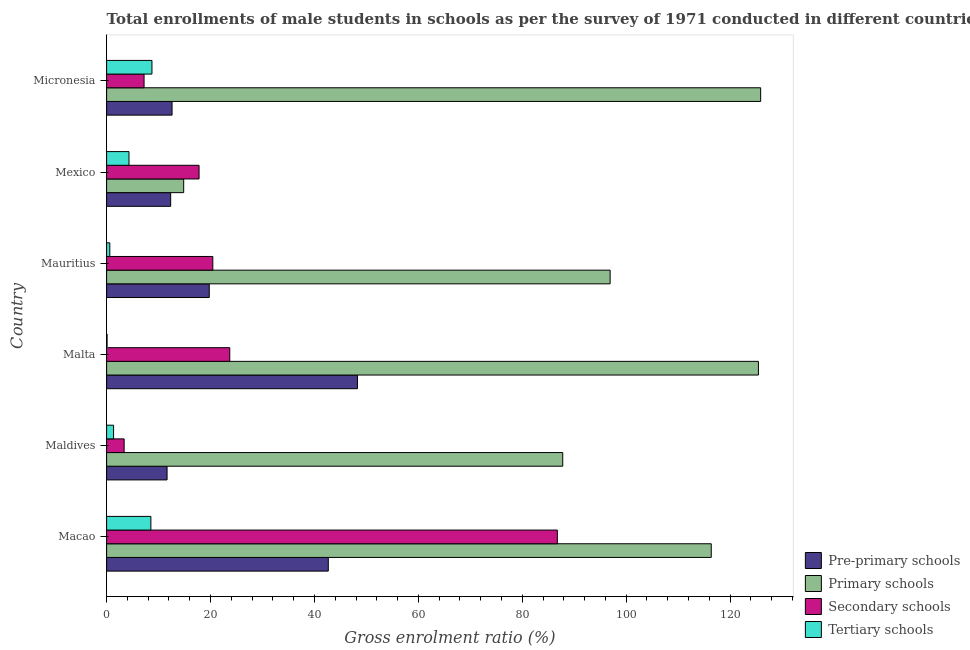How many different coloured bars are there?
Give a very brief answer. 4. How many groups of bars are there?
Provide a short and direct response. 6. Are the number of bars per tick equal to the number of legend labels?
Make the answer very short. Yes. Are the number of bars on each tick of the Y-axis equal?
Give a very brief answer. Yes. How many bars are there on the 5th tick from the top?
Ensure brevity in your answer.  4. What is the label of the 1st group of bars from the top?
Provide a succinct answer. Micronesia. In how many cases, is the number of bars for a given country not equal to the number of legend labels?
Your answer should be compact. 0. What is the gross enrolment ratio(male) in pre-primary schools in Maldives?
Your answer should be very brief. 11.64. Across all countries, what is the maximum gross enrolment ratio(male) in pre-primary schools?
Keep it short and to the point. 48.28. Across all countries, what is the minimum gross enrolment ratio(male) in primary schools?
Your answer should be very brief. 14.84. In which country was the gross enrolment ratio(male) in pre-primary schools maximum?
Your answer should be very brief. Malta. In which country was the gross enrolment ratio(male) in secondary schools minimum?
Ensure brevity in your answer.  Maldives. What is the total gross enrolment ratio(male) in primary schools in the graph?
Offer a very short reply. 567.22. What is the difference between the gross enrolment ratio(male) in primary schools in Macao and that in Micronesia?
Make the answer very short. -9.51. What is the difference between the gross enrolment ratio(male) in tertiary schools in Maldives and the gross enrolment ratio(male) in pre-primary schools in Micronesia?
Give a very brief answer. -11.25. What is the average gross enrolment ratio(male) in tertiary schools per country?
Give a very brief answer. 3.93. What is the difference between the gross enrolment ratio(male) in pre-primary schools and gross enrolment ratio(male) in primary schools in Maldives?
Ensure brevity in your answer.  -76.15. What is the ratio of the gross enrolment ratio(male) in pre-primary schools in Malta to that in Micronesia?
Provide a succinct answer. 3.83. What is the difference between the highest and the second highest gross enrolment ratio(male) in secondary schools?
Give a very brief answer. 63.05. What is the difference between the highest and the lowest gross enrolment ratio(male) in primary schools?
Offer a very short reply. 111.04. Is the sum of the gross enrolment ratio(male) in secondary schools in Mexico and Micronesia greater than the maximum gross enrolment ratio(male) in primary schools across all countries?
Your response must be concise. No. Is it the case that in every country, the sum of the gross enrolment ratio(male) in pre-primary schools and gross enrolment ratio(male) in tertiary schools is greater than the sum of gross enrolment ratio(male) in primary schools and gross enrolment ratio(male) in secondary schools?
Ensure brevity in your answer.  Yes. What does the 3rd bar from the top in Maldives represents?
Offer a very short reply. Primary schools. What does the 1st bar from the bottom in Micronesia represents?
Make the answer very short. Pre-primary schools. Is it the case that in every country, the sum of the gross enrolment ratio(male) in pre-primary schools and gross enrolment ratio(male) in primary schools is greater than the gross enrolment ratio(male) in secondary schools?
Make the answer very short. Yes. What is the difference between two consecutive major ticks on the X-axis?
Provide a succinct answer. 20. Are the values on the major ticks of X-axis written in scientific E-notation?
Make the answer very short. No. Does the graph contain any zero values?
Provide a short and direct response. No. How many legend labels are there?
Give a very brief answer. 4. What is the title of the graph?
Your response must be concise. Total enrollments of male students in schools as per the survey of 1971 conducted in different countries. What is the Gross enrolment ratio (%) in Pre-primary schools in Macao?
Your answer should be compact. 42.67. What is the Gross enrolment ratio (%) in Primary schools in Macao?
Provide a short and direct response. 116.37. What is the Gross enrolment ratio (%) in Secondary schools in Macao?
Ensure brevity in your answer.  86.75. What is the Gross enrolment ratio (%) in Tertiary schools in Macao?
Offer a very short reply. 8.52. What is the Gross enrolment ratio (%) in Pre-primary schools in Maldives?
Make the answer very short. 11.64. What is the Gross enrolment ratio (%) in Primary schools in Maldives?
Your answer should be compact. 87.79. What is the Gross enrolment ratio (%) in Secondary schools in Maldives?
Offer a very short reply. 3.38. What is the Gross enrolment ratio (%) in Tertiary schools in Maldives?
Keep it short and to the point. 1.34. What is the Gross enrolment ratio (%) in Pre-primary schools in Malta?
Your answer should be compact. 48.28. What is the Gross enrolment ratio (%) in Primary schools in Malta?
Offer a very short reply. 125.45. What is the Gross enrolment ratio (%) in Secondary schools in Malta?
Provide a short and direct response. 23.7. What is the Gross enrolment ratio (%) in Tertiary schools in Malta?
Provide a short and direct response. 0.09. What is the Gross enrolment ratio (%) in Pre-primary schools in Mauritius?
Provide a short and direct response. 19.76. What is the Gross enrolment ratio (%) in Primary schools in Mauritius?
Your answer should be very brief. 96.91. What is the Gross enrolment ratio (%) in Secondary schools in Mauritius?
Provide a succinct answer. 20.44. What is the Gross enrolment ratio (%) of Tertiary schools in Mauritius?
Your answer should be very brief. 0.62. What is the Gross enrolment ratio (%) of Pre-primary schools in Mexico?
Your answer should be compact. 12.33. What is the Gross enrolment ratio (%) in Primary schools in Mexico?
Provide a short and direct response. 14.84. What is the Gross enrolment ratio (%) of Secondary schools in Mexico?
Your answer should be very brief. 17.79. What is the Gross enrolment ratio (%) of Tertiary schools in Mexico?
Your response must be concise. 4.31. What is the Gross enrolment ratio (%) of Pre-primary schools in Micronesia?
Keep it short and to the point. 12.6. What is the Gross enrolment ratio (%) of Primary schools in Micronesia?
Keep it short and to the point. 125.88. What is the Gross enrolment ratio (%) in Secondary schools in Micronesia?
Offer a very short reply. 7.21. What is the Gross enrolment ratio (%) in Tertiary schools in Micronesia?
Make the answer very short. 8.73. Across all countries, what is the maximum Gross enrolment ratio (%) in Pre-primary schools?
Ensure brevity in your answer.  48.28. Across all countries, what is the maximum Gross enrolment ratio (%) of Primary schools?
Offer a very short reply. 125.88. Across all countries, what is the maximum Gross enrolment ratio (%) in Secondary schools?
Provide a succinct answer. 86.75. Across all countries, what is the maximum Gross enrolment ratio (%) of Tertiary schools?
Offer a very short reply. 8.73. Across all countries, what is the minimum Gross enrolment ratio (%) of Pre-primary schools?
Your response must be concise. 11.64. Across all countries, what is the minimum Gross enrolment ratio (%) of Primary schools?
Give a very brief answer. 14.84. Across all countries, what is the minimum Gross enrolment ratio (%) in Secondary schools?
Make the answer very short. 3.38. Across all countries, what is the minimum Gross enrolment ratio (%) of Tertiary schools?
Your answer should be compact. 0.09. What is the total Gross enrolment ratio (%) of Pre-primary schools in the graph?
Keep it short and to the point. 147.26. What is the total Gross enrolment ratio (%) of Primary schools in the graph?
Ensure brevity in your answer.  567.22. What is the total Gross enrolment ratio (%) of Secondary schools in the graph?
Provide a succinct answer. 159.27. What is the total Gross enrolment ratio (%) of Tertiary schools in the graph?
Your answer should be very brief. 23.6. What is the difference between the Gross enrolment ratio (%) of Pre-primary schools in Macao and that in Maldives?
Keep it short and to the point. 31.03. What is the difference between the Gross enrolment ratio (%) of Primary schools in Macao and that in Maldives?
Your answer should be very brief. 28.58. What is the difference between the Gross enrolment ratio (%) in Secondary schools in Macao and that in Maldives?
Your answer should be very brief. 83.37. What is the difference between the Gross enrolment ratio (%) in Tertiary schools in Macao and that in Maldives?
Make the answer very short. 7.18. What is the difference between the Gross enrolment ratio (%) of Pre-primary schools in Macao and that in Malta?
Offer a very short reply. -5.61. What is the difference between the Gross enrolment ratio (%) of Primary schools in Macao and that in Malta?
Your response must be concise. -9.08. What is the difference between the Gross enrolment ratio (%) in Secondary schools in Macao and that in Malta?
Give a very brief answer. 63.05. What is the difference between the Gross enrolment ratio (%) in Tertiary schools in Macao and that in Malta?
Keep it short and to the point. 8.43. What is the difference between the Gross enrolment ratio (%) of Pre-primary schools in Macao and that in Mauritius?
Your answer should be compact. 22.91. What is the difference between the Gross enrolment ratio (%) in Primary schools in Macao and that in Mauritius?
Your answer should be compact. 19.46. What is the difference between the Gross enrolment ratio (%) of Secondary schools in Macao and that in Mauritius?
Offer a very short reply. 66.31. What is the difference between the Gross enrolment ratio (%) in Tertiary schools in Macao and that in Mauritius?
Keep it short and to the point. 7.9. What is the difference between the Gross enrolment ratio (%) in Pre-primary schools in Macao and that in Mexico?
Your response must be concise. 30.33. What is the difference between the Gross enrolment ratio (%) in Primary schools in Macao and that in Mexico?
Offer a terse response. 101.53. What is the difference between the Gross enrolment ratio (%) in Secondary schools in Macao and that in Mexico?
Provide a succinct answer. 68.96. What is the difference between the Gross enrolment ratio (%) of Tertiary schools in Macao and that in Mexico?
Offer a terse response. 4.21. What is the difference between the Gross enrolment ratio (%) in Pre-primary schools in Macao and that in Micronesia?
Offer a terse response. 30.07. What is the difference between the Gross enrolment ratio (%) in Primary schools in Macao and that in Micronesia?
Provide a succinct answer. -9.51. What is the difference between the Gross enrolment ratio (%) in Secondary schools in Macao and that in Micronesia?
Your answer should be very brief. 79.54. What is the difference between the Gross enrolment ratio (%) in Tertiary schools in Macao and that in Micronesia?
Your answer should be compact. -0.21. What is the difference between the Gross enrolment ratio (%) in Pre-primary schools in Maldives and that in Malta?
Ensure brevity in your answer.  -36.64. What is the difference between the Gross enrolment ratio (%) in Primary schools in Maldives and that in Malta?
Offer a very short reply. -37.66. What is the difference between the Gross enrolment ratio (%) of Secondary schools in Maldives and that in Malta?
Your answer should be very brief. -20.33. What is the difference between the Gross enrolment ratio (%) in Tertiary schools in Maldives and that in Malta?
Your answer should be compact. 1.25. What is the difference between the Gross enrolment ratio (%) in Pre-primary schools in Maldives and that in Mauritius?
Ensure brevity in your answer.  -8.12. What is the difference between the Gross enrolment ratio (%) of Primary schools in Maldives and that in Mauritius?
Provide a succinct answer. -9.12. What is the difference between the Gross enrolment ratio (%) of Secondary schools in Maldives and that in Mauritius?
Your response must be concise. -17.06. What is the difference between the Gross enrolment ratio (%) of Tertiary schools in Maldives and that in Mauritius?
Your answer should be very brief. 0.73. What is the difference between the Gross enrolment ratio (%) in Pre-primary schools in Maldives and that in Mexico?
Your response must be concise. -0.69. What is the difference between the Gross enrolment ratio (%) in Primary schools in Maldives and that in Mexico?
Offer a very short reply. 72.95. What is the difference between the Gross enrolment ratio (%) in Secondary schools in Maldives and that in Mexico?
Make the answer very short. -14.42. What is the difference between the Gross enrolment ratio (%) of Tertiary schools in Maldives and that in Mexico?
Ensure brevity in your answer.  -2.97. What is the difference between the Gross enrolment ratio (%) in Pre-primary schools in Maldives and that in Micronesia?
Provide a short and direct response. -0.96. What is the difference between the Gross enrolment ratio (%) of Primary schools in Maldives and that in Micronesia?
Your response must be concise. -38.09. What is the difference between the Gross enrolment ratio (%) in Secondary schools in Maldives and that in Micronesia?
Offer a very short reply. -3.83. What is the difference between the Gross enrolment ratio (%) in Tertiary schools in Maldives and that in Micronesia?
Make the answer very short. -7.38. What is the difference between the Gross enrolment ratio (%) of Pre-primary schools in Malta and that in Mauritius?
Keep it short and to the point. 28.52. What is the difference between the Gross enrolment ratio (%) of Primary schools in Malta and that in Mauritius?
Keep it short and to the point. 28.54. What is the difference between the Gross enrolment ratio (%) in Secondary schools in Malta and that in Mauritius?
Your answer should be very brief. 3.26. What is the difference between the Gross enrolment ratio (%) of Tertiary schools in Malta and that in Mauritius?
Make the answer very short. -0.53. What is the difference between the Gross enrolment ratio (%) of Pre-primary schools in Malta and that in Mexico?
Give a very brief answer. 35.95. What is the difference between the Gross enrolment ratio (%) of Primary schools in Malta and that in Mexico?
Give a very brief answer. 110.61. What is the difference between the Gross enrolment ratio (%) in Secondary schools in Malta and that in Mexico?
Ensure brevity in your answer.  5.91. What is the difference between the Gross enrolment ratio (%) of Tertiary schools in Malta and that in Mexico?
Your answer should be very brief. -4.22. What is the difference between the Gross enrolment ratio (%) in Pre-primary schools in Malta and that in Micronesia?
Offer a very short reply. 35.68. What is the difference between the Gross enrolment ratio (%) of Primary schools in Malta and that in Micronesia?
Your answer should be compact. -0.43. What is the difference between the Gross enrolment ratio (%) of Secondary schools in Malta and that in Micronesia?
Make the answer very short. 16.49. What is the difference between the Gross enrolment ratio (%) in Tertiary schools in Malta and that in Micronesia?
Ensure brevity in your answer.  -8.64. What is the difference between the Gross enrolment ratio (%) of Pre-primary schools in Mauritius and that in Mexico?
Make the answer very short. 7.43. What is the difference between the Gross enrolment ratio (%) in Primary schools in Mauritius and that in Mexico?
Give a very brief answer. 82.07. What is the difference between the Gross enrolment ratio (%) of Secondary schools in Mauritius and that in Mexico?
Provide a short and direct response. 2.65. What is the difference between the Gross enrolment ratio (%) of Tertiary schools in Mauritius and that in Mexico?
Give a very brief answer. -3.69. What is the difference between the Gross enrolment ratio (%) of Pre-primary schools in Mauritius and that in Micronesia?
Provide a short and direct response. 7.16. What is the difference between the Gross enrolment ratio (%) of Primary schools in Mauritius and that in Micronesia?
Keep it short and to the point. -28.97. What is the difference between the Gross enrolment ratio (%) in Secondary schools in Mauritius and that in Micronesia?
Make the answer very short. 13.23. What is the difference between the Gross enrolment ratio (%) in Tertiary schools in Mauritius and that in Micronesia?
Offer a terse response. -8.11. What is the difference between the Gross enrolment ratio (%) in Pre-primary schools in Mexico and that in Micronesia?
Give a very brief answer. -0.27. What is the difference between the Gross enrolment ratio (%) of Primary schools in Mexico and that in Micronesia?
Your answer should be compact. -111.04. What is the difference between the Gross enrolment ratio (%) of Secondary schools in Mexico and that in Micronesia?
Your answer should be very brief. 10.58. What is the difference between the Gross enrolment ratio (%) of Tertiary schools in Mexico and that in Micronesia?
Offer a very short reply. -4.42. What is the difference between the Gross enrolment ratio (%) in Pre-primary schools in Macao and the Gross enrolment ratio (%) in Primary schools in Maldives?
Your response must be concise. -45.12. What is the difference between the Gross enrolment ratio (%) in Pre-primary schools in Macao and the Gross enrolment ratio (%) in Secondary schools in Maldives?
Ensure brevity in your answer.  39.29. What is the difference between the Gross enrolment ratio (%) in Pre-primary schools in Macao and the Gross enrolment ratio (%) in Tertiary schools in Maldives?
Your answer should be compact. 41.32. What is the difference between the Gross enrolment ratio (%) in Primary schools in Macao and the Gross enrolment ratio (%) in Secondary schools in Maldives?
Give a very brief answer. 112.99. What is the difference between the Gross enrolment ratio (%) of Primary schools in Macao and the Gross enrolment ratio (%) of Tertiary schools in Maldives?
Provide a short and direct response. 115.02. What is the difference between the Gross enrolment ratio (%) in Secondary schools in Macao and the Gross enrolment ratio (%) in Tertiary schools in Maldives?
Your answer should be very brief. 85.41. What is the difference between the Gross enrolment ratio (%) of Pre-primary schools in Macao and the Gross enrolment ratio (%) of Primary schools in Malta?
Provide a succinct answer. -82.78. What is the difference between the Gross enrolment ratio (%) in Pre-primary schools in Macao and the Gross enrolment ratio (%) in Secondary schools in Malta?
Keep it short and to the point. 18.96. What is the difference between the Gross enrolment ratio (%) of Pre-primary schools in Macao and the Gross enrolment ratio (%) of Tertiary schools in Malta?
Give a very brief answer. 42.58. What is the difference between the Gross enrolment ratio (%) of Primary schools in Macao and the Gross enrolment ratio (%) of Secondary schools in Malta?
Ensure brevity in your answer.  92.66. What is the difference between the Gross enrolment ratio (%) of Primary schools in Macao and the Gross enrolment ratio (%) of Tertiary schools in Malta?
Offer a very short reply. 116.28. What is the difference between the Gross enrolment ratio (%) in Secondary schools in Macao and the Gross enrolment ratio (%) in Tertiary schools in Malta?
Provide a short and direct response. 86.66. What is the difference between the Gross enrolment ratio (%) in Pre-primary schools in Macao and the Gross enrolment ratio (%) in Primary schools in Mauritius?
Your response must be concise. -54.24. What is the difference between the Gross enrolment ratio (%) of Pre-primary schools in Macao and the Gross enrolment ratio (%) of Secondary schools in Mauritius?
Your response must be concise. 22.23. What is the difference between the Gross enrolment ratio (%) of Pre-primary schools in Macao and the Gross enrolment ratio (%) of Tertiary schools in Mauritius?
Your answer should be compact. 42.05. What is the difference between the Gross enrolment ratio (%) of Primary schools in Macao and the Gross enrolment ratio (%) of Secondary schools in Mauritius?
Offer a terse response. 95.93. What is the difference between the Gross enrolment ratio (%) of Primary schools in Macao and the Gross enrolment ratio (%) of Tertiary schools in Mauritius?
Your answer should be compact. 115.75. What is the difference between the Gross enrolment ratio (%) in Secondary schools in Macao and the Gross enrolment ratio (%) in Tertiary schools in Mauritius?
Ensure brevity in your answer.  86.13. What is the difference between the Gross enrolment ratio (%) of Pre-primary schools in Macao and the Gross enrolment ratio (%) of Primary schools in Mexico?
Provide a succinct answer. 27.83. What is the difference between the Gross enrolment ratio (%) in Pre-primary schools in Macao and the Gross enrolment ratio (%) in Secondary schools in Mexico?
Provide a succinct answer. 24.87. What is the difference between the Gross enrolment ratio (%) of Pre-primary schools in Macao and the Gross enrolment ratio (%) of Tertiary schools in Mexico?
Your answer should be very brief. 38.36. What is the difference between the Gross enrolment ratio (%) of Primary schools in Macao and the Gross enrolment ratio (%) of Secondary schools in Mexico?
Your answer should be very brief. 98.58. What is the difference between the Gross enrolment ratio (%) of Primary schools in Macao and the Gross enrolment ratio (%) of Tertiary schools in Mexico?
Ensure brevity in your answer.  112.06. What is the difference between the Gross enrolment ratio (%) of Secondary schools in Macao and the Gross enrolment ratio (%) of Tertiary schools in Mexico?
Offer a terse response. 82.44. What is the difference between the Gross enrolment ratio (%) of Pre-primary schools in Macao and the Gross enrolment ratio (%) of Primary schools in Micronesia?
Your answer should be very brief. -83.21. What is the difference between the Gross enrolment ratio (%) of Pre-primary schools in Macao and the Gross enrolment ratio (%) of Secondary schools in Micronesia?
Keep it short and to the point. 35.46. What is the difference between the Gross enrolment ratio (%) of Pre-primary schools in Macao and the Gross enrolment ratio (%) of Tertiary schools in Micronesia?
Offer a very short reply. 33.94. What is the difference between the Gross enrolment ratio (%) of Primary schools in Macao and the Gross enrolment ratio (%) of Secondary schools in Micronesia?
Your answer should be compact. 109.16. What is the difference between the Gross enrolment ratio (%) of Primary schools in Macao and the Gross enrolment ratio (%) of Tertiary schools in Micronesia?
Provide a short and direct response. 107.64. What is the difference between the Gross enrolment ratio (%) of Secondary schools in Macao and the Gross enrolment ratio (%) of Tertiary schools in Micronesia?
Give a very brief answer. 78.02. What is the difference between the Gross enrolment ratio (%) in Pre-primary schools in Maldives and the Gross enrolment ratio (%) in Primary schools in Malta?
Keep it short and to the point. -113.81. What is the difference between the Gross enrolment ratio (%) in Pre-primary schools in Maldives and the Gross enrolment ratio (%) in Secondary schools in Malta?
Give a very brief answer. -12.07. What is the difference between the Gross enrolment ratio (%) of Pre-primary schools in Maldives and the Gross enrolment ratio (%) of Tertiary schools in Malta?
Your answer should be compact. 11.55. What is the difference between the Gross enrolment ratio (%) in Primary schools in Maldives and the Gross enrolment ratio (%) in Secondary schools in Malta?
Provide a succinct answer. 64.08. What is the difference between the Gross enrolment ratio (%) of Primary schools in Maldives and the Gross enrolment ratio (%) of Tertiary schools in Malta?
Make the answer very short. 87.7. What is the difference between the Gross enrolment ratio (%) of Secondary schools in Maldives and the Gross enrolment ratio (%) of Tertiary schools in Malta?
Offer a very short reply. 3.29. What is the difference between the Gross enrolment ratio (%) of Pre-primary schools in Maldives and the Gross enrolment ratio (%) of Primary schools in Mauritius?
Keep it short and to the point. -85.27. What is the difference between the Gross enrolment ratio (%) of Pre-primary schools in Maldives and the Gross enrolment ratio (%) of Secondary schools in Mauritius?
Provide a succinct answer. -8.8. What is the difference between the Gross enrolment ratio (%) in Pre-primary schools in Maldives and the Gross enrolment ratio (%) in Tertiary schools in Mauritius?
Make the answer very short. 11.02. What is the difference between the Gross enrolment ratio (%) of Primary schools in Maldives and the Gross enrolment ratio (%) of Secondary schools in Mauritius?
Your answer should be very brief. 67.35. What is the difference between the Gross enrolment ratio (%) of Primary schools in Maldives and the Gross enrolment ratio (%) of Tertiary schools in Mauritius?
Your response must be concise. 87.17. What is the difference between the Gross enrolment ratio (%) of Secondary schools in Maldives and the Gross enrolment ratio (%) of Tertiary schools in Mauritius?
Make the answer very short. 2.76. What is the difference between the Gross enrolment ratio (%) in Pre-primary schools in Maldives and the Gross enrolment ratio (%) in Primary schools in Mexico?
Provide a succinct answer. -3.2. What is the difference between the Gross enrolment ratio (%) in Pre-primary schools in Maldives and the Gross enrolment ratio (%) in Secondary schools in Mexico?
Your response must be concise. -6.16. What is the difference between the Gross enrolment ratio (%) in Pre-primary schools in Maldives and the Gross enrolment ratio (%) in Tertiary schools in Mexico?
Your response must be concise. 7.33. What is the difference between the Gross enrolment ratio (%) of Primary schools in Maldives and the Gross enrolment ratio (%) of Secondary schools in Mexico?
Offer a terse response. 69.99. What is the difference between the Gross enrolment ratio (%) of Primary schools in Maldives and the Gross enrolment ratio (%) of Tertiary schools in Mexico?
Make the answer very short. 83.48. What is the difference between the Gross enrolment ratio (%) in Secondary schools in Maldives and the Gross enrolment ratio (%) in Tertiary schools in Mexico?
Your answer should be very brief. -0.93. What is the difference between the Gross enrolment ratio (%) of Pre-primary schools in Maldives and the Gross enrolment ratio (%) of Primary schools in Micronesia?
Your answer should be very brief. -114.24. What is the difference between the Gross enrolment ratio (%) in Pre-primary schools in Maldives and the Gross enrolment ratio (%) in Secondary schools in Micronesia?
Make the answer very short. 4.43. What is the difference between the Gross enrolment ratio (%) of Pre-primary schools in Maldives and the Gross enrolment ratio (%) of Tertiary schools in Micronesia?
Provide a succinct answer. 2.91. What is the difference between the Gross enrolment ratio (%) in Primary schools in Maldives and the Gross enrolment ratio (%) in Secondary schools in Micronesia?
Offer a very short reply. 80.58. What is the difference between the Gross enrolment ratio (%) in Primary schools in Maldives and the Gross enrolment ratio (%) in Tertiary schools in Micronesia?
Provide a short and direct response. 79.06. What is the difference between the Gross enrolment ratio (%) in Secondary schools in Maldives and the Gross enrolment ratio (%) in Tertiary schools in Micronesia?
Your answer should be very brief. -5.35. What is the difference between the Gross enrolment ratio (%) of Pre-primary schools in Malta and the Gross enrolment ratio (%) of Primary schools in Mauritius?
Ensure brevity in your answer.  -48.63. What is the difference between the Gross enrolment ratio (%) in Pre-primary schools in Malta and the Gross enrolment ratio (%) in Secondary schools in Mauritius?
Offer a very short reply. 27.84. What is the difference between the Gross enrolment ratio (%) in Pre-primary schools in Malta and the Gross enrolment ratio (%) in Tertiary schools in Mauritius?
Make the answer very short. 47.66. What is the difference between the Gross enrolment ratio (%) in Primary schools in Malta and the Gross enrolment ratio (%) in Secondary schools in Mauritius?
Your answer should be very brief. 105.01. What is the difference between the Gross enrolment ratio (%) in Primary schools in Malta and the Gross enrolment ratio (%) in Tertiary schools in Mauritius?
Keep it short and to the point. 124.83. What is the difference between the Gross enrolment ratio (%) of Secondary schools in Malta and the Gross enrolment ratio (%) of Tertiary schools in Mauritius?
Offer a very short reply. 23.09. What is the difference between the Gross enrolment ratio (%) in Pre-primary schools in Malta and the Gross enrolment ratio (%) in Primary schools in Mexico?
Give a very brief answer. 33.44. What is the difference between the Gross enrolment ratio (%) of Pre-primary schools in Malta and the Gross enrolment ratio (%) of Secondary schools in Mexico?
Your answer should be very brief. 30.48. What is the difference between the Gross enrolment ratio (%) of Pre-primary schools in Malta and the Gross enrolment ratio (%) of Tertiary schools in Mexico?
Ensure brevity in your answer.  43.97. What is the difference between the Gross enrolment ratio (%) of Primary schools in Malta and the Gross enrolment ratio (%) of Secondary schools in Mexico?
Offer a very short reply. 107.66. What is the difference between the Gross enrolment ratio (%) in Primary schools in Malta and the Gross enrolment ratio (%) in Tertiary schools in Mexico?
Offer a terse response. 121.14. What is the difference between the Gross enrolment ratio (%) of Secondary schools in Malta and the Gross enrolment ratio (%) of Tertiary schools in Mexico?
Keep it short and to the point. 19.39. What is the difference between the Gross enrolment ratio (%) of Pre-primary schools in Malta and the Gross enrolment ratio (%) of Primary schools in Micronesia?
Ensure brevity in your answer.  -77.6. What is the difference between the Gross enrolment ratio (%) of Pre-primary schools in Malta and the Gross enrolment ratio (%) of Secondary schools in Micronesia?
Provide a short and direct response. 41.07. What is the difference between the Gross enrolment ratio (%) in Pre-primary schools in Malta and the Gross enrolment ratio (%) in Tertiary schools in Micronesia?
Offer a very short reply. 39.55. What is the difference between the Gross enrolment ratio (%) of Primary schools in Malta and the Gross enrolment ratio (%) of Secondary schools in Micronesia?
Keep it short and to the point. 118.24. What is the difference between the Gross enrolment ratio (%) in Primary schools in Malta and the Gross enrolment ratio (%) in Tertiary schools in Micronesia?
Make the answer very short. 116.72. What is the difference between the Gross enrolment ratio (%) in Secondary schools in Malta and the Gross enrolment ratio (%) in Tertiary schools in Micronesia?
Ensure brevity in your answer.  14.98. What is the difference between the Gross enrolment ratio (%) of Pre-primary schools in Mauritius and the Gross enrolment ratio (%) of Primary schools in Mexico?
Keep it short and to the point. 4.92. What is the difference between the Gross enrolment ratio (%) in Pre-primary schools in Mauritius and the Gross enrolment ratio (%) in Secondary schools in Mexico?
Offer a terse response. 1.96. What is the difference between the Gross enrolment ratio (%) of Pre-primary schools in Mauritius and the Gross enrolment ratio (%) of Tertiary schools in Mexico?
Make the answer very short. 15.45. What is the difference between the Gross enrolment ratio (%) of Primary schools in Mauritius and the Gross enrolment ratio (%) of Secondary schools in Mexico?
Give a very brief answer. 79.11. What is the difference between the Gross enrolment ratio (%) of Primary schools in Mauritius and the Gross enrolment ratio (%) of Tertiary schools in Mexico?
Make the answer very short. 92.6. What is the difference between the Gross enrolment ratio (%) of Secondary schools in Mauritius and the Gross enrolment ratio (%) of Tertiary schools in Mexico?
Ensure brevity in your answer.  16.13. What is the difference between the Gross enrolment ratio (%) of Pre-primary schools in Mauritius and the Gross enrolment ratio (%) of Primary schools in Micronesia?
Ensure brevity in your answer.  -106.12. What is the difference between the Gross enrolment ratio (%) in Pre-primary schools in Mauritius and the Gross enrolment ratio (%) in Secondary schools in Micronesia?
Make the answer very short. 12.55. What is the difference between the Gross enrolment ratio (%) of Pre-primary schools in Mauritius and the Gross enrolment ratio (%) of Tertiary schools in Micronesia?
Give a very brief answer. 11.03. What is the difference between the Gross enrolment ratio (%) of Primary schools in Mauritius and the Gross enrolment ratio (%) of Secondary schools in Micronesia?
Keep it short and to the point. 89.7. What is the difference between the Gross enrolment ratio (%) of Primary schools in Mauritius and the Gross enrolment ratio (%) of Tertiary schools in Micronesia?
Your response must be concise. 88.18. What is the difference between the Gross enrolment ratio (%) in Secondary schools in Mauritius and the Gross enrolment ratio (%) in Tertiary schools in Micronesia?
Give a very brief answer. 11.71. What is the difference between the Gross enrolment ratio (%) in Pre-primary schools in Mexico and the Gross enrolment ratio (%) in Primary schools in Micronesia?
Give a very brief answer. -113.55. What is the difference between the Gross enrolment ratio (%) in Pre-primary schools in Mexico and the Gross enrolment ratio (%) in Secondary schools in Micronesia?
Keep it short and to the point. 5.12. What is the difference between the Gross enrolment ratio (%) of Pre-primary schools in Mexico and the Gross enrolment ratio (%) of Tertiary schools in Micronesia?
Keep it short and to the point. 3.6. What is the difference between the Gross enrolment ratio (%) of Primary schools in Mexico and the Gross enrolment ratio (%) of Secondary schools in Micronesia?
Provide a succinct answer. 7.63. What is the difference between the Gross enrolment ratio (%) of Primary schools in Mexico and the Gross enrolment ratio (%) of Tertiary schools in Micronesia?
Offer a very short reply. 6.11. What is the difference between the Gross enrolment ratio (%) of Secondary schools in Mexico and the Gross enrolment ratio (%) of Tertiary schools in Micronesia?
Provide a short and direct response. 9.07. What is the average Gross enrolment ratio (%) of Pre-primary schools per country?
Offer a terse response. 24.54. What is the average Gross enrolment ratio (%) in Primary schools per country?
Your response must be concise. 94.54. What is the average Gross enrolment ratio (%) of Secondary schools per country?
Offer a very short reply. 26.54. What is the average Gross enrolment ratio (%) in Tertiary schools per country?
Keep it short and to the point. 3.93. What is the difference between the Gross enrolment ratio (%) of Pre-primary schools and Gross enrolment ratio (%) of Primary schools in Macao?
Ensure brevity in your answer.  -73.7. What is the difference between the Gross enrolment ratio (%) in Pre-primary schools and Gross enrolment ratio (%) in Secondary schools in Macao?
Give a very brief answer. -44.08. What is the difference between the Gross enrolment ratio (%) of Pre-primary schools and Gross enrolment ratio (%) of Tertiary schools in Macao?
Your answer should be compact. 34.15. What is the difference between the Gross enrolment ratio (%) of Primary schools and Gross enrolment ratio (%) of Secondary schools in Macao?
Offer a very short reply. 29.62. What is the difference between the Gross enrolment ratio (%) of Primary schools and Gross enrolment ratio (%) of Tertiary schools in Macao?
Offer a terse response. 107.85. What is the difference between the Gross enrolment ratio (%) of Secondary schools and Gross enrolment ratio (%) of Tertiary schools in Macao?
Offer a very short reply. 78.23. What is the difference between the Gross enrolment ratio (%) of Pre-primary schools and Gross enrolment ratio (%) of Primary schools in Maldives?
Your answer should be compact. -76.15. What is the difference between the Gross enrolment ratio (%) in Pre-primary schools and Gross enrolment ratio (%) in Secondary schools in Maldives?
Offer a very short reply. 8.26. What is the difference between the Gross enrolment ratio (%) in Pre-primary schools and Gross enrolment ratio (%) in Tertiary schools in Maldives?
Your response must be concise. 10.29. What is the difference between the Gross enrolment ratio (%) in Primary schools and Gross enrolment ratio (%) in Secondary schools in Maldives?
Keep it short and to the point. 84.41. What is the difference between the Gross enrolment ratio (%) in Primary schools and Gross enrolment ratio (%) in Tertiary schools in Maldives?
Provide a short and direct response. 86.44. What is the difference between the Gross enrolment ratio (%) in Secondary schools and Gross enrolment ratio (%) in Tertiary schools in Maldives?
Offer a terse response. 2.03. What is the difference between the Gross enrolment ratio (%) of Pre-primary schools and Gross enrolment ratio (%) of Primary schools in Malta?
Offer a very short reply. -77.17. What is the difference between the Gross enrolment ratio (%) of Pre-primary schools and Gross enrolment ratio (%) of Secondary schools in Malta?
Give a very brief answer. 24.57. What is the difference between the Gross enrolment ratio (%) in Pre-primary schools and Gross enrolment ratio (%) in Tertiary schools in Malta?
Make the answer very short. 48.19. What is the difference between the Gross enrolment ratio (%) in Primary schools and Gross enrolment ratio (%) in Secondary schools in Malta?
Offer a very short reply. 101.75. What is the difference between the Gross enrolment ratio (%) of Primary schools and Gross enrolment ratio (%) of Tertiary schools in Malta?
Keep it short and to the point. 125.36. What is the difference between the Gross enrolment ratio (%) of Secondary schools and Gross enrolment ratio (%) of Tertiary schools in Malta?
Ensure brevity in your answer.  23.61. What is the difference between the Gross enrolment ratio (%) in Pre-primary schools and Gross enrolment ratio (%) in Primary schools in Mauritius?
Your response must be concise. -77.15. What is the difference between the Gross enrolment ratio (%) of Pre-primary schools and Gross enrolment ratio (%) of Secondary schools in Mauritius?
Your response must be concise. -0.68. What is the difference between the Gross enrolment ratio (%) of Pre-primary schools and Gross enrolment ratio (%) of Tertiary schools in Mauritius?
Provide a short and direct response. 19.14. What is the difference between the Gross enrolment ratio (%) of Primary schools and Gross enrolment ratio (%) of Secondary schools in Mauritius?
Offer a terse response. 76.47. What is the difference between the Gross enrolment ratio (%) in Primary schools and Gross enrolment ratio (%) in Tertiary schools in Mauritius?
Make the answer very short. 96.29. What is the difference between the Gross enrolment ratio (%) in Secondary schools and Gross enrolment ratio (%) in Tertiary schools in Mauritius?
Make the answer very short. 19.82. What is the difference between the Gross enrolment ratio (%) of Pre-primary schools and Gross enrolment ratio (%) of Primary schools in Mexico?
Offer a very short reply. -2.51. What is the difference between the Gross enrolment ratio (%) of Pre-primary schools and Gross enrolment ratio (%) of Secondary schools in Mexico?
Provide a succinct answer. -5.46. What is the difference between the Gross enrolment ratio (%) of Pre-primary schools and Gross enrolment ratio (%) of Tertiary schools in Mexico?
Your response must be concise. 8.02. What is the difference between the Gross enrolment ratio (%) of Primary schools and Gross enrolment ratio (%) of Secondary schools in Mexico?
Keep it short and to the point. -2.96. What is the difference between the Gross enrolment ratio (%) in Primary schools and Gross enrolment ratio (%) in Tertiary schools in Mexico?
Your answer should be compact. 10.53. What is the difference between the Gross enrolment ratio (%) in Secondary schools and Gross enrolment ratio (%) in Tertiary schools in Mexico?
Provide a succinct answer. 13.48. What is the difference between the Gross enrolment ratio (%) in Pre-primary schools and Gross enrolment ratio (%) in Primary schools in Micronesia?
Keep it short and to the point. -113.28. What is the difference between the Gross enrolment ratio (%) in Pre-primary schools and Gross enrolment ratio (%) in Secondary schools in Micronesia?
Make the answer very short. 5.39. What is the difference between the Gross enrolment ratio (%) in Pre-primary schools and Gross enrolment ratio (%) in Tertiary schools in Micronesia?
Offer a very short reply. 3.87. What is the difference between the Gross enrolment ratio (%) in Primary schools and Gross enrolment ratio (%) in Secondary schools in Micronesia?
Make the answer very short. 118.67. What is the difference between the Gross enrolment ratio (%) of Primary schools and Gross enrolment ratio (%) of Tertiary schools in Micronesia?
Give a very brief answer. 117.15. What is the difference between the Gross enrolment ratio (%) in Secondary schools and Gross enrolment ratio (%) in Tertiary schools in Micronesia?
Keep it short and to the point. -1.52. What is the ratio of the Gross enrolment ratio (%) in Pre-primary schools in Macao to that in Maldives?
Provide a succinct answer. 3.67. What is the ratio of the Gross enrolment ratio (%) of Primary schools in Macao to that in Maldives?
Give a very brief answer. 1.33. What is the ratio of the Gross enrolment ratio (%) in Secondary schools in Macao to that in Maldives?
Offer a terse response. 25.7. What is the ratio of the Gross enrolment ratio (%) in Tertiary schools in Macao to that in Maldives?
Your answer should be compact. 6.35. What is the ratio of the Gross enrolment ratio (%) of Pre-primary schools in Macao to that in Malta?
Your answer should be compact. 0.88. What is the ratio of the Gross enrolment ratio (%) in Primary schools in Macao to that in Malta?
Offer a very short reply. 0.93. What is the ratio of the Gross enrolment ratio (%) of Secondary schools in Macao to that in Malta?
Your answer should be very brief. 3.66. What is the ratio of the Gross enrolment ratio (%) of Tertiary schools in Macao to that in Malta?
Make the answer very short. 95.26. What is the ratio of the Gross enrolment ratio (%) of Pre-primary schools in Macao to that in Mauritius?
Provide a succinct answer. 2.16. What is the ratio of the Gross enrolment ratio (%) of Primary schools in Macao to that in Mauritius?
Provide a short and direct response. 1.2. What is the ratio of the Gross enrolment ratio (%) of Secondary schools in Macao to that in Mauritius?
Offer a very short reply. 4.24. What is the ratio of the Gross enrolment ratio (%) of Tertiary schools in Macao to that in Mauritius?
Give a very brief answer. 13.84. What is the ratio of the Gross enrolment ratio (%) of Pre-primary schools in Macao to that in Mexico?
Keep it short and to the point. 3.46. What is the ratio of the Gross enrolment ratio (%) in Primary schools in Macao to that in Mexico?
Offer a terse response. 7.84. What is the ratio of the Gross enrolment ratio (%) of Secondary schools in Macao to that in Mexico?
Your answer should be very brief. 4.88. What is the ratio of the Gross enrolment ratio (%) in Tertiary schools in Macao to that in Mexico?
Offer a terse response. 1.98. What is the ratio of the Gross enrolment ratio (%) of Pre-primary schools in Macao to that in Micronesia?
Offer a terse response. 3.39. What is the ratio of the Gross enrolment ratio (%) in Primary schools in Macao to that in Micronesia?
Make the answer very short. 0.92. What is the ratio of the Gross enrolment ratio (%) in Secondary schools in Macao to that in Micronesia?
Keep it short and to the point. 12.03. What is the ratio of the Gross enrolment ratio (%) of Tertiary schools in Macao to that in Micronesia?
Keep it short and to the point. 0.98. What is the ratio of the Gross enrolment ratio (%) of Pre-primary schools in Maldives to that in Malta?
Give a very brief answer. 0.24. What is the ratio of the Gross enrolment ratio (%) of Primary schools in Maldives to that in Malta?
Make the answer very short. 0.7. What is the ratio of the Gross enrolment ratio (%) of Secondary schools in Maldives to that in Malta?
Make the answer very short. 0.14. What is the ratio of the Gross enrolment ratio (%) of Tertiary schools in Maldives to that in Malta?
Ensure brevity in your answer.  15.01. What is the ratio of the Gross enrolment ratio (%) in Pre-primary schools in Maldives to that in Mauritius?
Offer a very short reply. 0.59. What is the ratio of the Gross enrolment ratio (%) in Primary schools in Maldives to that in Mauritius?
Make the answer very short. 0.91. What is the ratio of the Gross enrolment ratio (%) of Secondary schools in Maldives to that in Mauritius?
Your answer should be compact. 0.17. What is the ratio of the Gross enrolment ratio (%) in Tertiary schools in Maldives to that in Mauritius?
Ensure brevity in your answer.  2.18. What is the ratio of the Gross enrolment ratio (%) of Pre-primary schools in Maldives to that in Mexico?
Offer a terse response. 0.94. What is the ratio of the Gross enrolment ratio (%) in Primary schools in Maldives to that in Mexico?
Provide a succinct answer. 5.92. What is the ratio of the Gross enrolment ratio (%) of Secondary schools in Maldives to that in Mexico?
Ensure brevity in your answer.  0.19. What is the ratio of the Gross enrolment ratio (%) in Tertiary schools in Maldives to that in Mexico?
Your answer should be compact. 0.31. What is the ratio of the Gross enrolment ratio (%) in Pre-primary schools in Maldives to that in Micronesia?
Provide a short and direct response. 0.92. What is the ratio of the Gross enrolment ratio (%) of Primary schools in Maldives to that in Micronesia?
Offer a terse response. 0.7. What is the ratio of the Gross enrolment ratio (%) of Secondary schools in Maldives to that in Micronesia?
Make the answer very short. 0.47. What is the ratio of the Gross enrolment ratio (%) in Tertiary schools in Maldives to that in Micronesia?
Your answer should be compact. 0.15. What is the ratio of the Gross enrolment ratio (%) in Pre-primary schools in Malta to that in Mauritius?
Your answer should be compact. 2.44. What is the ratio of the Gross enrolment ratio (%) in Primary schools in Malta to that in Mauritius?
Ensure brevity in your answer.  1.29. What is the ratio of the Gross enrolment ratio (%) in Secondary schools in Malta to that in Mauritius?
Make the answer very short. 1.16. What is the ratio of the Gross enrolment ratio (%) in Tertiary schools in Malta to that in Mauritius?
Provide a short and direct response. 0.15. What is the ratio of the Gross enrolment ratio (%) of Pre-primary schools in Malta to that in Mexico?
Provide a short and direct response. 3.92. What is the ratio of the Gross enrolment ratio (%) of Primary schools in Malta to that in Mexico?
Your answer should be very brief. 8.46. What is the ratio of the Gross enrolment ratio (%) of Secondary schools in Malta to that in Mexico?
Your answer should be compact. 1.33. What is the ratio of the Gross enrolment ratio (%) of Tertiary schools in Malta to that in Mexico?
Your answer should be compact. 0.02. What is the ratio of the Gross enrolment ratio (%) of Pre-primary schools in Malta to that in Micronesia?
Make the answer very short. 3.83. What is the ratio of the Gross enrolment ratio (%) of Primary schools in Malta to that in Micronesia?
Give a very brief answer. 1. What is the ratio of the Gross enrolment ratio (%) in Secondary schools in Malta to that in Micronesia?
Your answer should be very brief. 3.29. What is the ratio of the Gross enrolment ratio (%) of Tertiary schools in Malta to that in Micronesia?
Make the answer very short. 0.01. What is the ratio of the Gross enrolment ratio (%) in Pre-primary schools in Mauritius to that in Mexico?
Give a very brief answer. 1.6. What is the ratio of the Gross enrolment ratio (%) in Primary schools in Mauritius to that in Mexico?
Your answer should be very brief. 6.53. What is the ratio of the Gross enrolment ratio (%) of Secondary schools in Mauritius to that in Mexico?
Provide a short and direct response. 1.15. What is the ratio of the Gross enrolment ratio (%) in Tertiary schools in Mauritius to that in Mexico?
Your answer should be very brief. 0.14. What is the ratio of the Gross enrolment ratio (%) in Pre-primary schools in Mauritius to that in Micronesia?
Ensure brevity in your answer.  1.57. What is the ratio of the Gross enrolment ratio (%) of Primary schools in Mauritius to that in Micronesia?
Ensure brevity in your answer.  0.77. What is the ratio of the Gross enrolment ratio (%) in Secondary schools in Mauritius to that in Micronesia?
Offer a very short reply. 2.84. What is the ratio of the Gross enrolment ratio (%) of Tertiary schools in Mauritius to that in Micronesia?
Make the answer very short. 0.07. What is the ratio of the Gross enrolment ratio (%) in Pre-primary schools in Mexico to that in Micronesia?
Offer a very short reply. 0.98. What is the ratio of the Gross enrolment ratio (%) of Primary schools in Mexico to that in Micronesia?
Make the answer very short. 0.12. What is the ratio of the Gross enrolment ratio (%) of Secondary schools in Mexico to that in Micronesia?
Make the answer very short. 2.47. What is the ratio of the Gross enrolment ratio (%) of Tertiary schools in Mexico to that in Micronesia?
Make the answer very short. 0.49. What is the difference between the highest and the second highest Gross enrolment ratio (%) of Pre-primary schools?
Provide a short and direct response. 5.61. What is the difference between the highest and the second highest Gross enrolment ratio (%) of Primary schools?
Give a very brief answer. 0.43. What is the difference between the highest and the second highest Gross enrolment ratio (%) of Secondary schools?
Offer a very short reply. 63.05. What is the difference between the highest and the second highest Gross enrolment ratio (%) in Tertiary schools?
Make the answer very short. 0.21. What is the difference between the highest and the lowest Gross enrolment ratio (%) of Pre-primary schools?
Your answer should be very brief. 36.64. What is the difference between the highest and the lowest Gross enrolment ratio (%) of Primary schools?
Make the answer very short. 111.04. What is the difference between the highest and the lowest Gross enrolment ratio (%) of Secondary schools?
Give a very brief answer. 83.37. What is the difference between the highest and the lowest Gross enrolment ratio (%) in Tertiary schools?
Offer a terse response. 8.64. 